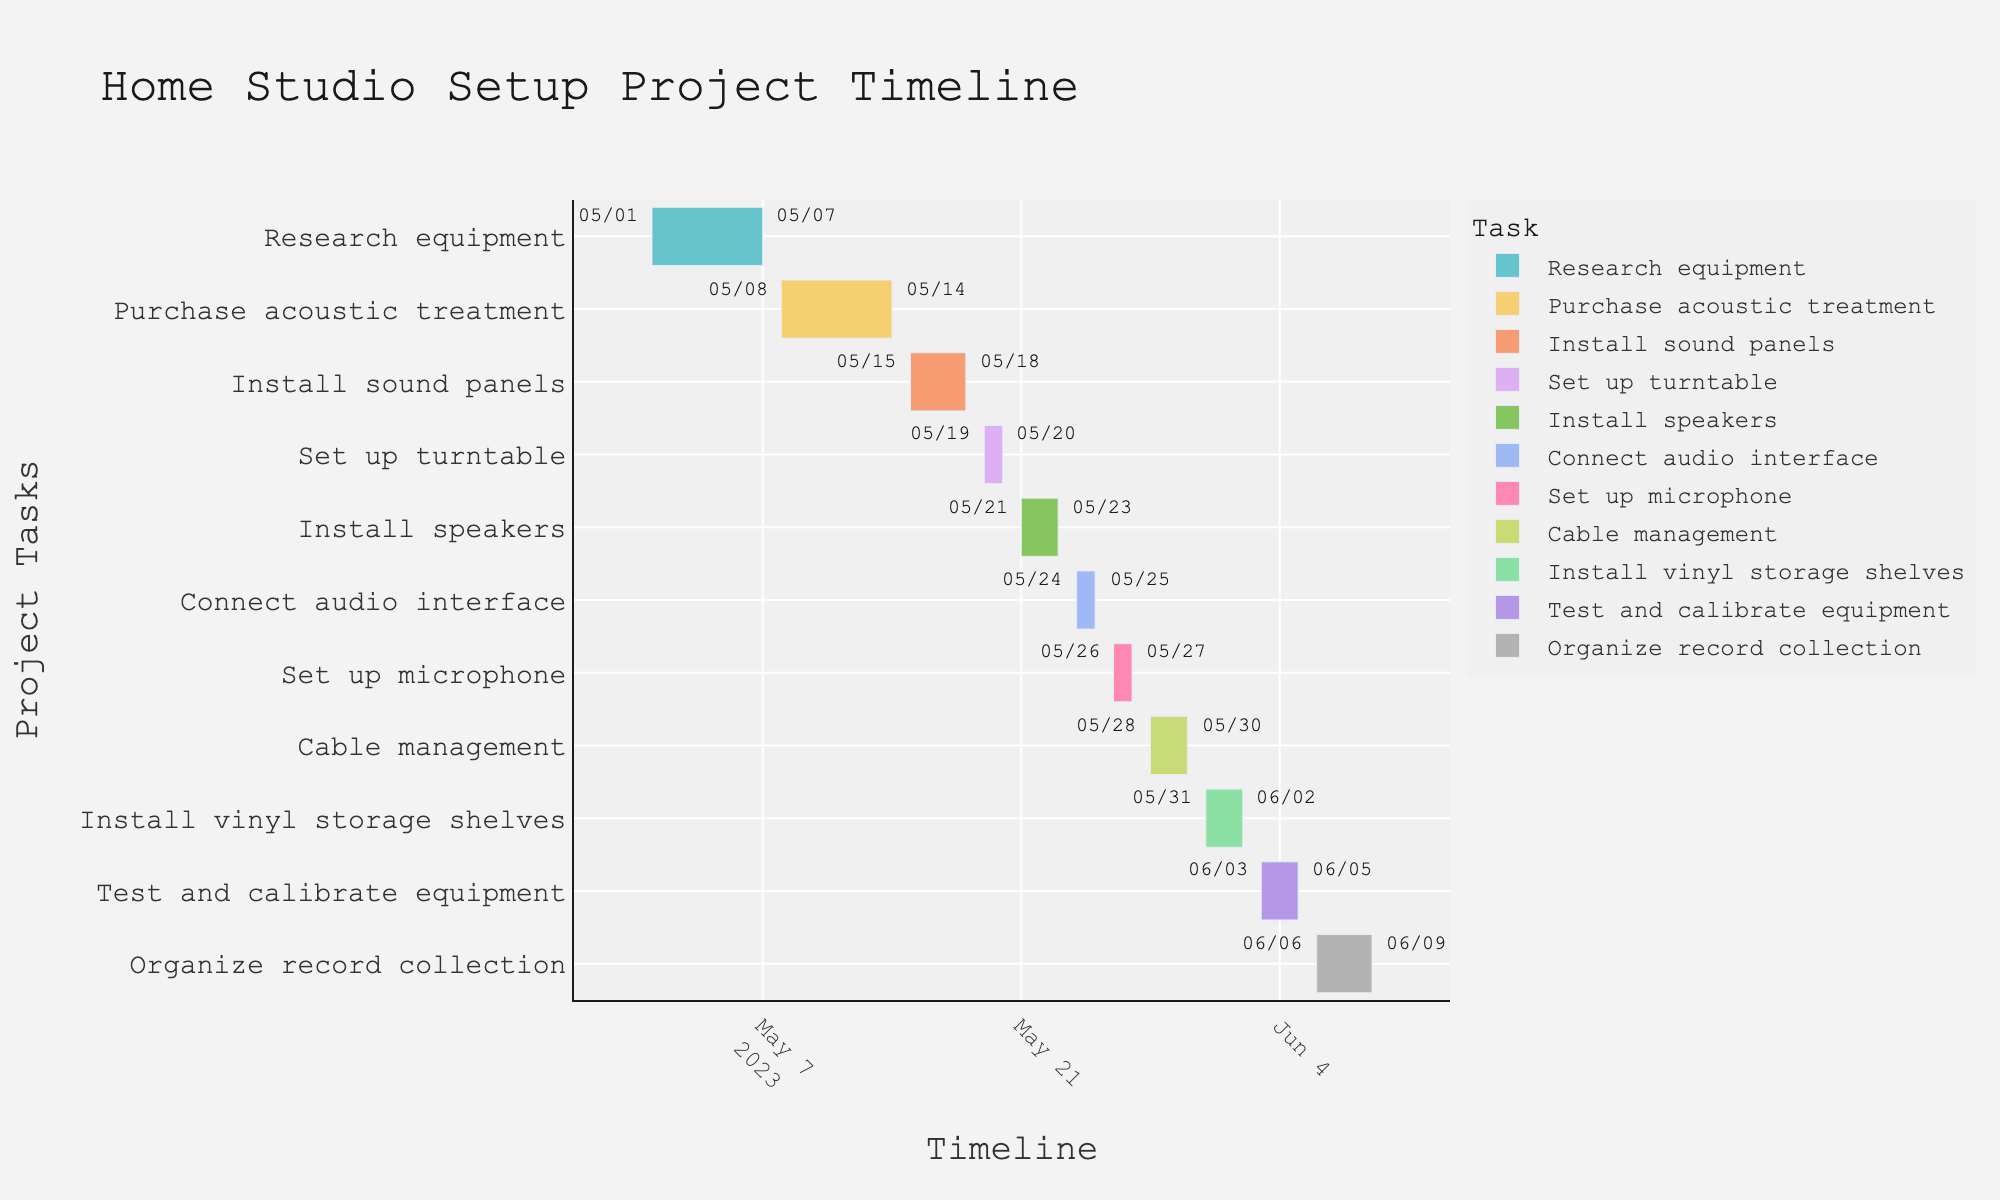What is the first task in the home studio setup project? The first task is the one that appears at the top of the Y-axis in the Gantt chart.
Answer: Research equipment When does the 'Install speakers' task start and end? Referring to the task labeled 'Install speakers', check the associated start and end dates on the X-axis.
Answer: May 21 to May 23 Which task takes the longest time to complete? Look for the task that spans the most time on the Gantt chart by comparing the lengths of the bars.
Answer: Organize record collection How many tasks are scheduled to be completed by the end of May 2023? Count the number of tasks with end dates on or before May 31, 2023.
Answer: 8 Which phase of the project overlaps with 'Install sound panels'? Identify tasks whose timeline bars overlap with the 'Install sound panels' space on the Gantt chart.
Answer: Set up turntable What is the total duration of the 'Test and calibrate equipment' task in days? Subtract the start date from the end date to find the total duration in days. Each segment represents a day.
Answer: 3 days How many tasks are scheduled to be completed within the month of June 2023? Count the tasks whose end dates fall within the range of June 1, 2023, to June 30, 2023.
Answer: 2 Which task immediately follows the 'Install vinyl storage shelves' task? Look for the task that begins right after the end date of 'Install vinyl storage shelves' on the Gantt chart.
Answer: Test and calibrate equipment 